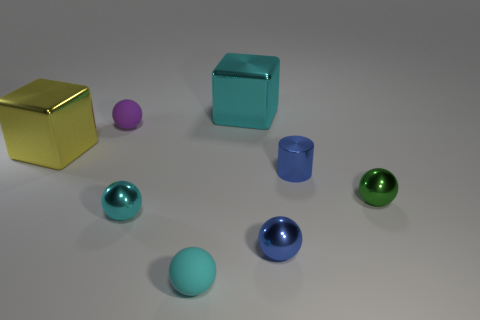Subtract all green spheres. How many spheres are left? 4 Subtract all small cyan metal balls. How many balls are left? 4 Subtract all purple balls. Subtract all brown cylinders. How many balls are left? 4 Add 1 cyan matte spheres. How many objects exist? 9 Subtract all cylinders. How many objects are left? 7 Subtract 0 gray cubes. How many objects are left? 8 Subtract all tiny green shiny things. Subtract all small green balls. How many objects are left? 6 Add 2 green shiny balls. How many green shiny balls are left? 3 Add 2 small cyan objects. How many small cyan objects exist? 4 